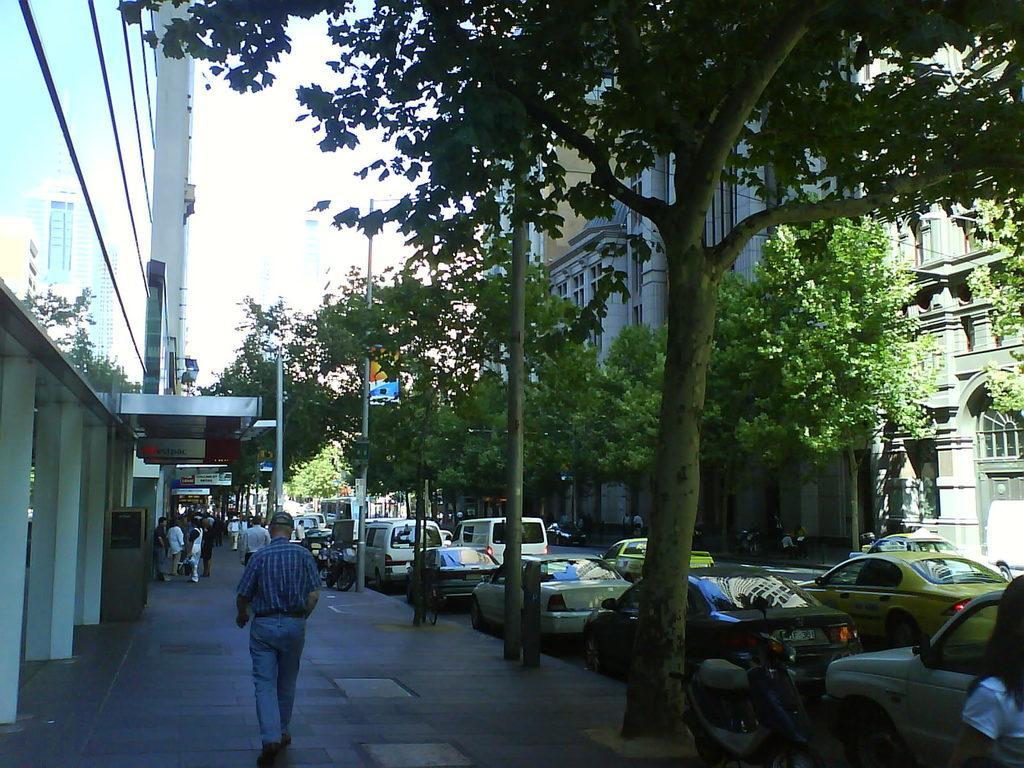In one or two sentences, can you explain what this image depicts? In this image on the right side and left side there are some buildings, trees, poles and in the center there are some vehicles on a road. On the left side there are some people who are walking on a footpath, and at the top of the image there is sky. 